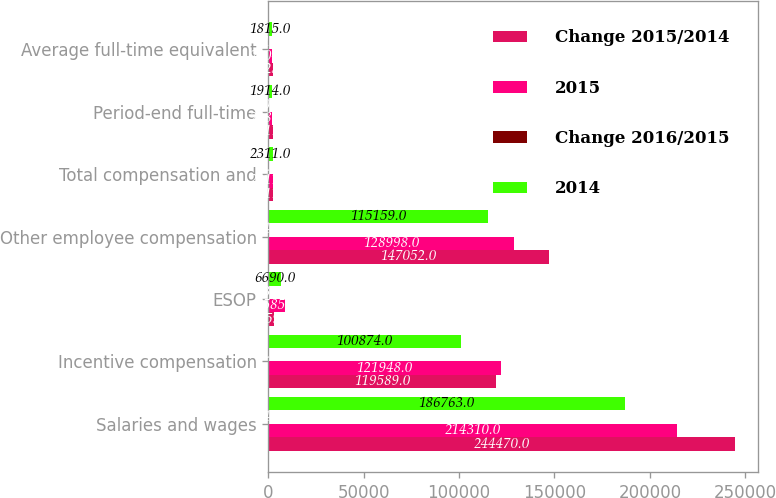<chart> <loc_0><loc_0><loc_500><loc_500><stacked_bar_chart><ecel><fcel>Salaries and wages<fcel>Incentive compensation<fcel>ESOP<fcel>Other employee compensation<fcel>Total compensation and<fcel>Period-end full-time<fcel>Average full-time equivalent<nl><fcel>Change 2015/2014<fcel>244470<fcel>119589<fcel>3159<fcel>147052<fcel>2311<fcel>2311<fcel>2225<nl><fcel>2015<fcel>214310<fcel>121948<fcel>8585<fcel>128998<fcel>2311<fcel>2089<fcel>2004<nl><fcel>Change 2016/2015<fcel>14.1<fcel>1.9<fcel>63.2<fcel>14<fcel>8.5<fcel>10.6<fcel>11<nl><fcel>2014<fcel>186763<fcel>100874<fcel>6690<fcel>115159<fcel>2311<fcel>1914<fcel>1815<nl></chart> 